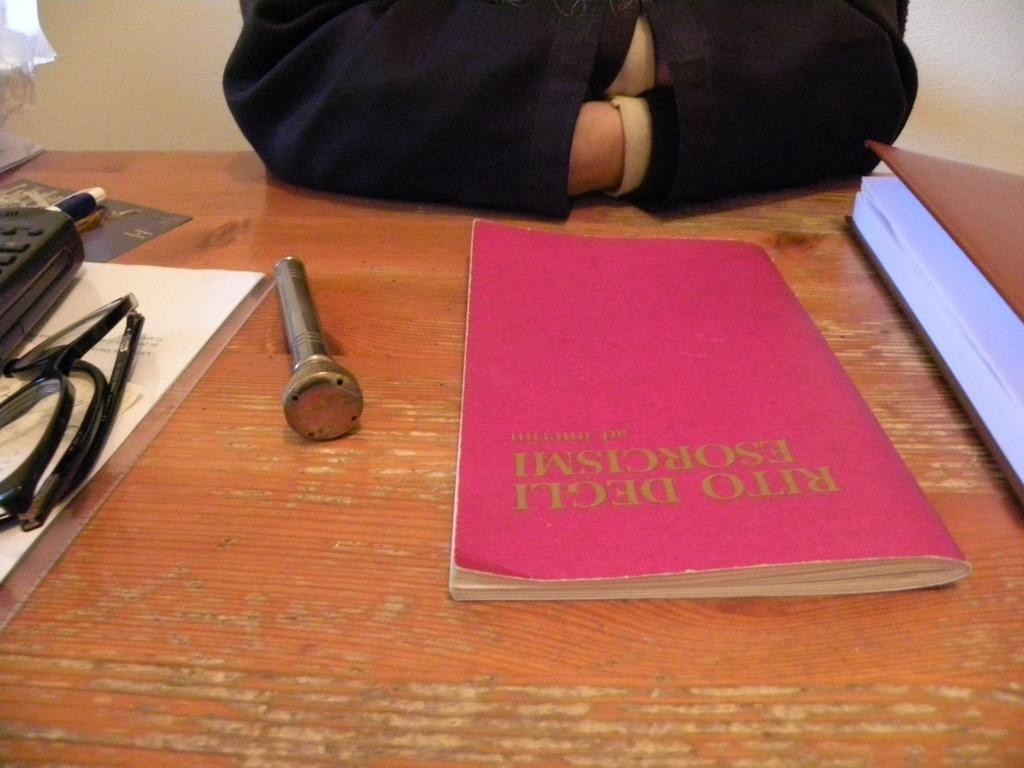<image>
Present a compact description of the photo's key features. The artist of the small book is Rito Degli 